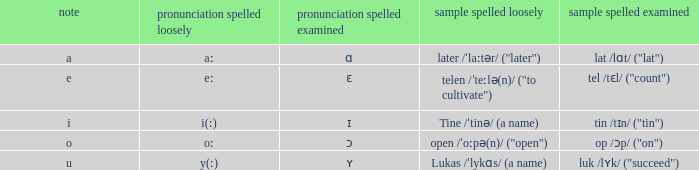What is Pronunciation Spelled Free, when Pronunciation Spelled Checked is "ɛ"? Eː. 